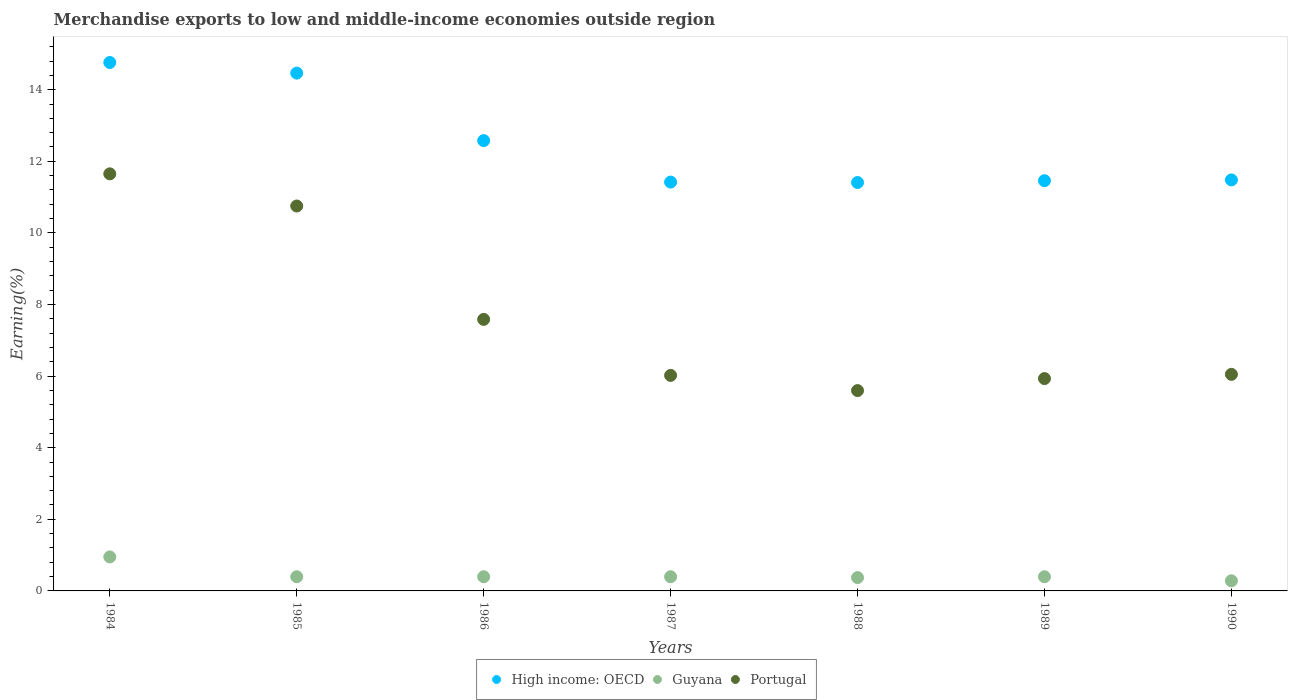What is the percentage of amount earned from merchandise exports in Portugal in 1986?
Your answer should be very brief. 7.58. Across all years, what is the maximum percentage of amount earned from merchandise exports in Portugal?
Offer a very short reply. 11.65. Across all years, what is the minimum percentage of amount earned from merchandise exports in Guyana?
Provide a short and direct response. 0.28. In which year was the percentage of amount earned from merchandise exports in Portugal minimum?
Provide a short and direct response. 1988. What is the total percentage of amount earned from merchandise exports in Portugal in the graph?
Your answer should be very brief. 53.58. What is the difference between the percentage of amount earned from merchandise exports in Guyana in 1985 and that in 1987?
Offer a terse response. -7.184997041775887e-11. What is the difference between the percentage of amount earned from merchandise exports in Guyana in 1984 and the percentage of amount earned from merchandise exports in Portugal in 1989?
Your answer should be very brief. -4.98. What is the average percentage of amount earned from merchandise exports in Portugal per year?
Ensure brevity in your answer.  7.65. In the year 1988, what is the difference between the percentage of amount earned from merchandise exports in Guyana and percentage of amount earned from merchandise exports in Portugal?
Offer a very short reply. -5.22. In how many years, is the percentage of amount earned from merchandise exports in High income: OECD greater than 6.4 %?
Provide a succinct answer. 7. What is the ratio of the percentage of amount earned from merchandise exports in Portugal in 1985 to that in 1988?
Your response must be concise. 1.92. Is the percentage of amount earned from merchandise exports in Portugal in 1988 less than that in 1990?
Offer a very short reply. Yes. What is the difference between the highest and the second highest percentage of amount earned from merchandise exports in High income: OECD?
Offer a very short reply. 0.3. What is the difference between the highest and the lowest percentage of amount earned from merchandise exports in High income: OECD?
Offer a terse response. 3.35. In how many years, is the percentage of amount earned from merchandise exports in Guyana greater than the average percentage of amount earned from merchandise exports in Guyana taken over all years?
Ensure brevity in your answer.  1. Is it the case that in every year, the sum of the percentage of amount earned from merchandise exports in Guyana and percentage of amount earned from merchandise exports in High income: OECD  is greater than the percentage of amount earned from merchandise exports in Portugal?
Provide a short and direct response. Yes. Does the percentage of amount earned from merchandise exports in High income: OECD monotonically increase over the years?
Provide a short and direct response. No. Is the percentage of amount earned from merchandise exports in Portugal strictly greater than the percentage of amount earned from merchandise exports in High income: OECD over the years?
Your response must be concise. No. How many dotlines are there?
Make the answer very short. 3. How many years are there in the graph?
Offer a very short reply. 7. What is the difference between two consecutive major ticks on the Y-axis?
Your answer should be compact. 2. Does the graph contain grids?
Provide a succinct answer. No. Where does the legend appear in the graph?
Provide a succinct answer. Bottom center. How many legend labels are there?
Your response must be concise. 3. How are the legend labels stacked?
Make the answer very short. Horizontal. What is the title of the graph?
Keep it short and to the point. Merchandise exports to low and middle-income economies outside region. Does "Croatia" appear as one of the legend labels in the graph?
Offer a terse response. No. What is the label or title of the Y-axis?
Offer a very short reply. Earning(%). What is the Earning(%) of High income: OECD in 1984?
Give a very brief answer. 14.76. What is the Earning(%) in Guyana in 1984?
Provide a short and direct response. 0.95. What is the Earning(%) in Portugal in 1984?
Make the answer very short. 11.65. What is the Earning(%) in High income: OECD in 1985?
Your answer should be compact. 14.46. What is the Earning(%) in Guyana in 1985?
Offer a very short reply. 0.4. What is the Earning(%) of Portugal in 1985?
Offer a terse response. 10.75. What is the Earning(%) in High income: OECD in 1986?
Offer a very short reply. 12.58. What is the Earning(%) in Guyana in 1986?
Keep it short and to the point. 0.4. What is the Earning(%) of Portugal in 1986?
Keep it short and to the point. 7.58. What is the Earning(%) of High income: OECD in 1987?
Provide a succinct answer. 11.42. What is the Earning(%) of Guyana in 1987?
Your response must be concise. 0.4. What is the Earning(%) of Portugal in 1987?
Provide a short and direct response. 6.02. What is the Earning(%) of High income: OECD in 1988?
Provide a short and direct response. 11.41. What is the Earning(%) in Guyana in 1988?
Offer a very short reply. 0.37. What is the Earning(%) of Portugal in 1988?
Give a very brief answer. 5.6. What is the Earning(%) of High income: OECD in 1989?
Your answer should be very brief. 11.46. What is the Earning(%) of Guyana in 1989?
Keep it short and to the point. 0.4. What is the Earning(%) of Portugal in 1989?
Make the answer very short. 5.93. What is the Earning(%) in High income: OECD in 1990?
Ensure brevity in your answer.  11.48. What is the Earning(%) of Guyana in 1990?
Offer a terse response. 0.28. What is the Earning(%) in Portugal in 1990?
Offer a terse response. 6.05. Across all years, what is the maximum Earning(%) of High income: OECD?
Give a very brief answer. 14.76. Across all years, what is the maximum Earning(%) of Guyana?
Your answer should be compact. 0.95. Across all years, what is the maximum Earning(%) of Portugal?
Your answer should be compact. 11.65. Across all years, what is the minimum Earning(%) of High income: OECD?
Your answer should be very brief. 11.41. Across all years, what is the minimum Earning(%) in Guyana?
Provide a succinct answer. 0.28. Across all years, what is the minimum Earning(%) in Portugal?
Your response must be concise. 5.6. What is the total Earning(%) in High income: OECD in the graph?
Offer a terse response. 87.56. What is the total Earning(%) of Guyana in the graph?
Provide a short and direct response. 3.19. What is the total Earning(%) in Portugal in the graph?
Provide a short and direct response. 53.58. What is the difference between the Earning(%) in High income: OECD in 1984 and that in 1985?
Make the answer very short. 0.3. What is the difference between the Earning(%) of Guyana in 1984 and that in 1985?
Provide a succinct answer. 0.55. What is the difference between the Earning(%) in Portugal in 1984 and that in 1985?
Your response must be concise. 0.9. What is the difference between the Earning(%) in High income: OECD in 1984 and that in 1986?
Your answer should be very brief. 2.18. What is the difference between the Earning(%) in Guyana in 1984 and that in 1986?
Provide a succinct answer. 0.55. What is the difference between the Earning(%) in Portugal in 1984 and that in 1986?
Provide a short and direct response. 4.06. What is the difference between the Earning(%) in High income: OECD in 1984 and that in 1987?
Provide a succinct answer. 3.34. What is the difference between the Earning(%) in Guyana in 1984 and that in 1987?
Your answer should be compact. 0.55. What is the difference between the Earning(%) in Portugal in 1984 and that in 1987?
Provide a succinct answer. 5.63. What is the difference between the Earning(%) of High income: OECD in 1984 and that in 1988?
Your answer should be very brief. 3.35. What is the difference between the Earning(%) of Guyana in 1984 and that in 1988?
Keep it short and to the point. 0.58. What is the difference between the Earning(%) in Portugal in 1984 and that in 1988?
Give a very brief answer. 6.05. What is the difference between the Earning(%) in High income: OECD in 1984 and that in 1989?
Offer a very short reply. 3.3. What is the difference between the Earning(%) of Guyana in 1984 and that in 1989?
Provide a short and direct response. 0.55. What is the difference between the Earning(%) in Portugal in 1984 and that in 1989?
Your response must be concise. 5.72. What is the difference between the Earning(%) in High income: OECD in 1984 and that in 1990?
Give a very brief answer. 3.28. What is the difference between the Earning(%) in Guyana in 1984 and that in 1990?
Your response must be concise. 0.67. What is the difference between the Earning(%) of Portugal in 1984 and that in 1990?
Your answer should be compact. 5.6. What is the difference between the Earning(%) of High income: OECD in 1985 and that in 1986?
Your answer should be compact. 1.89. What is the difference between the Earning(%) in Portugal in 1985 and that in 1986?
Provide a succinct answer. 3.17. What is the difference between the Earning(%) in High income: OECD in 1985 and that in 1987?
Your answer should be compact. 3.04. What is the difference between the Earning(%) of Portugal in 1985 and that in 1987?
Your response must be concise. 4.73. What is the difference between the Earning(%) in High income: OECD in 1985 and that in 1988?
Your response must be concise. 3.06. What is the difference between the Earning(%) of Guyana in 1985 and that in 1988?
Your response must be concise. 0.02. What is the difference between the Earning(%) of Portugal in 1985 and that in 1988?
Give a very brief answer. 5.16. What is the difference between the Earning(%) of High income: OECD in 1985 and that in 1989?
Keep it short and to the point. 3.01. What is the difference between the Earning(%) of Guyana in 1985 and that in 1989?
Provide a short and direct response. 0. What is the difference between the Earning(%) in Portugal in 1985 and that in 1989?
Make the answer very short. 4.82. What is the difference between the Earning(%) of High income: OECD in 1985 and that in 1990?
Offer a very short reply. 2.98. What is the difference between the Earning(%) in Guyana in 1985 and that in 1990?
Keep it short and to the point. 0.11. What is the difference between the Earning(%) in Portugal in 1985 and that in 1990?
Your answer should be compact. 4.7. What is the difference between the Earning(%) of High income: OECD in 1986 and that in 1987?
Your response must be concise. 1.16. What is the difference between the Earning(%) in Portugal in 1986 and that in 1987?
Your answer should be compact. 1.56. What is the difference between the Earning(%) in High income: OECD in 1986 and that in 1988?
Your response must be concise. 1.17. What is the difference between the Earning(%) of Guyana in 1986 and that in 1988?
Your answer should be very brief. 0.02. What is the difference between the Earning(%) of Portugal in 1986 and that in 1988?
Offer a terse response. 1.99. What is the difference between the Earning(%) in High income: OECD in 1986 and that in 1989?
Your answer should be compact. 1.12. What is the difference between the Earning(%) of Portugal in 1986 and that in 1989?
Your response must be concise. 1.65. What is the difference between the Earning(%) of High income: OECD in 1986 and that in 1990?
Provide a succinct answer. 1.1. What is the difference between the Earning(%) of Guyana in 1986 and that in 1990?
Provide a short and direct response. 0.11. What is the difference between the Earning(%) of Portugal in 1986 and that in 1990?
Offer a terse response. 1.54. What is the difference between the Earning(%) in High income: OECD in 1987 and that in 1988?
Keep it short and to the point. 0.01. What is the difference between the Earning(%) of Guyana in 1987 and that in 1988?
Your answer should be compact. 0.02. What is the difference between the Earning(%) in Portugal in 1987 and that in 1988?
Ensure brevity in your answer.  0.42. What is the difference between the Earning(%) in High income: OECD in 1987 and that in 1989?
Provide a short and direct response. -0.04. What is the difference between the Earning(%) of Portugal in 1987 and that in 1989?
Offer a terse response. 0.09. What is the difference between the Earning(%) of High income: OECD in 1987 and that in 1990?
Make the answer very short. -0.06. What is the difference between the Earning(%) of Guyana in 1987 and that in 1990?
Provide a succinct answer. 0.11. What is the difference between the Earning(%) of Portugal in 1987 and that in 1990?
Keep it short and to the point. -0.03. What is the difference between the Earning(%) of High income: OECD in 1988 and that in 1989?
Give a very brief answer. -0.05. What is the difference between the Earning(%) in Guyana in 1988 and that in 1989?
Your answer should be compact. -0.02. What is the difference between the Earning(%) in Portugal in 1988 and that in 1989?
Your answer should be very brief. -0.33. What is the difference between the Earning(%) of High income: OECD in 1988 and that in 1990?
Your answer should be compact. -0.07. What is the difference between the Earning(%) in Guyana in 1988 and that in 1990?
Your response must be concise. 0.09. What is the difference between the Earning(%) in Portugal in 1988 and that in 1990?
Keep it short and to the point. -0.45. What is the difference between the Earning(%) in High income: OECD in 1989 and that in 1990?
Keep it short and to the point. -0.02. What is the difference between the Earning(%) of Guyana in 1989 and that in 1990?
Your answer should be compact. 0.11. What is the difference between the Earning(%) of Portugal in 1989 and that in 1990?
Offer a terse response. -0.12. What is the difference between the Earning(%) of High income: OECD in 1984 and the Earning(%) of Guyana in 1985?
Provide a short and direct response. 14.36. What is the difference between the Earning(%) in High income: OECD in 1984 and the Earning(%) in Portugal in 1985?
Your answer should be compact. 4.01. What is the difference between the Earning(%) of Guyana in 1984 and the Earning(%) of Portugal in 1985?
Your answer should be compact. -9.8. What is the difference between the Earning(%) in High income: OECD in 1984 and the Earning(%) in Guyana in 1986?
Ensure brevity in your answer.  14.36. What is the difference between the Earning(%) of High income: OECD in 1984 and the Earning(%) of Portugal in 1986?
Provide a succinct answer. 7.17. What is the difference between the Earning(%) in Guyana in 1984 and the Earning(%) in Portugal in 1986?
Offer a terse response. -6.63. What is the difference between the Earning(%) in High income: OECD in 1984 and the Earning(%) in Guyana in 1987?
Your answer should be very brief. 14.36. What is the difference between the Earning(%) of High income: OECD in 1984 and the Earning(%) of Portugal in 1987?
Provide a succinct answer. 8.74. What is the difference between the Earning(%) of Guyana in 1984 and the Earning(%) of Portugal in 1987?
Keep it short and to the point. -5.07. What is the difference between the Earning(%) in High income: OECD in 1984 and the Earning(%) in Guyana in 1988?
Your response must be concise. 14.39. What is the difference between the Earning(%) in High income: OECD in 1984 and the Earning(%) in Portugal in 1988?
Keep it short and to the point. 9.16. What is the difference between the Earning(%) in Guyana in 1984 and the Earning(%) in Portugal in 1988?
Your answer should be compact. -4.65. What is the difference between the Earning(%) of High income: OECD in 1984 and the Earning(%) of Guyana in 1989?
Ensure brevity in your answer.  14.36. What is the difference between the Earning(%) in High income: OECD in 1984 and the Earning(%) in Portugal in 1989?
Provide a succinct answer. 8.83. What is the difference between the Earning(%) in Guyana in 1984 and the Earning(%) in Portugal in 1989?
Your response must be concise. -4.98. What is the difference between the Earning(%) of High income: OECD in 1984 and the Earning(%) of Guyana in 1990?
Your response must be concise. 14.48. What is the difference between the Earning(%) in High income: OECD in 1984 and the Earning(%) in Portugal in 1990?
Provide a short and direct response. 8.71. What is the difference between the Earning(%) in Guyana in 1984 and the Earning(%) in Portugal in 1990?
Make the answer very short. -5.1. What is the difference between the Earning(%) in High income: OECD in 1985 and the Earning(%) in Guyana in 1986?
Your answer should be compact. 14.07. What is the difference between the Earning(%) in High income: OECD in 1985 and the Earning(%) in Portugal in 1986?
Provide a short and direct response. 6.88. What is the difference between the Earning(%) in Guyana in 1985 and the Earning(%) in Portugal in 1986?
Make the answer very short. -7.19. What is the difference between the Earning(%) of High income: OECD in 1985 and the Earning(%) of Guyana in 1987?
Your answer should be very brief. 14.07. What is the difference between the Earning(%) in High income: OECD in 1985 and the Earning(%) in Portugal in 1987?
Your response must be concise. 8.44. What is the difference between the Earning(%) in Guyana in 1985 and the Earning(%) in Portugal in 1987?
Offer a very short reply. -5.62. What is the difference between the Earning(%) of High income: OECD in 1985 and the Earning(%) of Guyana in 1988?
Your response must be concise. 14.09. What is the difference between the Earning(%) of High income: OECD in 1985 and the Earning(%) of Portugal in 1988?
Your answer should be compact. 8.87. What is the difference between the Earning(%) in Guyana in 1985 and the Earning(%) in Portugal in 1988?
Make the answer very short. -5.2. What is the difference between the Earning(%) of High income: OECD in 1985 and the Earning(%) of Guyana in 1989?
Your answer should be very brief. 14.07. What is the difference between the Earning(%) of High income: OECD in 1985 and the Earning(%) of Portugal in 1989?
Keep it short and to the point. 8.53. What is the difference between the Earning(%) of Guyana in 1985 and the Earning(%) of Portugal in 1989?
Give a very brief answer. -5.53. What is the difference between the Earning(%) in High income: OECD in 1985 and the Earning(%) in Guyana in 1990?
Provide a succinct answer. 14.18. What is the difference between the Earning(%) in High income: OECD in 1985 and the Earning(%) in Portugal in 1990?
Your response must be concise. 8.41. What is the difference between the Earning(%) of Guyana in 1985 and the Earning(%) of Portugal in 1990?
Keep it short and to the point. -5.65. What is the difference between the Earning(%) of High income: OECD in 1986 and the Earning(%) of Guyana in 1987?
Provide a short and direct response. 12.18. What is the difference between the Earning(%) of High income: OECD in 1986 and the Earning(%) of Portugal in 1987?
Offer a terse response. 6.56. What is the difference between the Earning(%) in Guyana in 1986 and the Earning(%) in Portugal in 1987?
Your answer should be compact. -5.62. What is the difference between the Earning(%) in High income: OECD in 1986 and the Earning(%) in Guyana in 1988?
Make the answer very short. 12.21. What is the difference between the Earning(%) in High income: OECD in 1986 and the Earning(%) in Portugal in 1988?
Your answer should be very brief. 6.98. What is the difference between the Earning(%) of Guyana in 1986 and the Earning(%) of Portugal in 1988?
Ensure brevity in your answer.  -5.2. What is the difference between the Earning(%) of High income: OECD in 1986 and the Earning(%) of Guyana in 1989?
Provide a short and direct response. 12.18. What is the difference between the Earning(%) in High income: OECD in 1986 and the Earning(%) in Portugal in 1989?
Provide a short and direct response. 6.65. What is the difference between the Earning(%) of Guyana in 1986 and the Earning(%) of Portugal in 1989?
Keep it short and to the point. -5.53. What is the difference between the Earning(%) of High income: OECD in 1986 and the Earning(%) of Guyana in 1990?
Provide a succinct answer. 12.29. What is the difference between the Earning(%) in High income: OECD in 1986 and the Earning(%) in Portugal in 1990?
Give a very brief answer. 6.53. What is the difference between the Earning(%) in Guyana in 1986 and the Earning(%) in Portugal in 1990?
Offer a terse response. -5.65. What is the difference between the Earning(%) in High income: OECD in 1987 and the Earning(%) in Guyana in 1988?
Offer a very short reply. 11.05. What is the difference between the Earning(%) of High income: OECD in 1987 and the Earning(%) of Portugal in 1988?
Your answer should be compact. 5.82. What is the difference between the Earning(%) in Guyana in 1987 and the Earning(%) in Portugal in 1988?
Your answer should be compact. -5.2. What is the difference between the Earning(%) of High income: OECD in 1987 and the Earning(%) of Guyana in 1989?
Make the answer very short. 11.02. What is the difference between the Earning(%) in High income: OECD in 1987 and the Earning(%) in Portugal in 1989?
Your answer should be compact. 5.49. What is the difference between the Earning(%) of Guyana in 1987 and the Earning(%) of Portugal in 1989?
Your response must be concise. -5.53. What is the difference between the Earning(%) in High income: OECD in 1987 and the Earning(%) in Guyana in 1990?
Provide a short and direct response. 11.14. What is the difference between the Earning(%) of High income: OECD in 1987 and the Earning(%) of Portugal in 1990?
Offer a very short reply. 5.37. What is the difference between the Earning(%) of Guyana in 1987 and the Earning(%) of Portugal in 1990?
Provide a short and direct response. -5.65. What is the difference between the Earning(%) in High income: OECD in 1988 and the Earning(%) in Guyana in 1989?
Your answer should be very brief. 11.01. What is the difference between the Earning(%) in High income: OECD in 1988 and the Earning(%) in Portugal in 1989?
Ensure brevity in your answer.  5.48. What is the difference between the Earning(%) of Guyana in 1988 and the Earning(%) of Portugal in 1989?
Give a very brief answer. -5.56. What is the difference between the Earning(%) in High income: OECD in 1988 and the Earning(%) in Guyana in 1990?
Provide a short and direct response. 11.12. What is the difference between the Earning(%) in High income: OECD in 1988 and the Earning(%) in Portugal in 1990?
Your response must be concise. 5.36. What is the difference between the Earning(%) in Guyana in 1988 and the Earning(%) in Portugal in 1990?
Ensure brevity in your answer.  -5.68. What is the difference between the Earning(%) of High income: OECD in 1989 and the Earning(%) of Guyana in 1990?
Your response must be concise. 11.17. What is the difference between the Earning(%) in High income: OECD in 1989 and the Earning(%) in Portugal in 1990?
Your answer should be compact. 5.41. What is the difference between the Earning(%) of Guyana in 1989 and the Earning(%) of Portugal in 1990?
Provide a short and direct response. -5.65. What is the average Earning(%) of High income: OECD per year?
Your answer should be very brief. 12.51. What is the average Earning(%) in Guyana per year?
Provide a short and direct response. 0.46. What is the average Earning(%) in Portugal per year?
Offer a very short reply. 7.65. In the year 1984, what is the difference between the Earning(%) in High income: OECD and Earning(%) in Guyana?
Provide a short and direct response. 13.81. In the year 1984, what is the difference between the Earning(%) in High income: OECD and Earning(%) in Portugal?
Offer a very short reply. 3.11. In the year 1984, what is the difference between the Earning(%) of Guyana and Earning(%) of Portugal?
Ensure brevity in your answer.  -10.7. In the year 1985, what is the difference between the Earning(%) in High income: OECD and Earning(%) in Guyana?
Offer a terse response. 14.07. In the year 1985, what is the difference between the Earning(%) of High income: OECD and Earning(%) of Portugal?
Provide a short and direct response. 3.71. In the year 1985, what is the difference between the Earning(%) of Guyana and Earning(%) of Portugal?
Provide a short and direct response. -10.35. In the year 1986, what is the difference between the Earning(%) in High income: OECD and Earning(%) in Guyana?
Give a very brief answer. 12.18. In the year 1986, what is the difference between the Earning(%) of High income: OECD and Earning(%) of Portugal?
Ensure brevity in your answer.  4.99. In the year 1986, what is the difference between the Earning(%) of Guyana and Earning(%) of Portugal?
Provide a succinct answer. -7.19. In the year 1987, what is the difference between the Earning(%) in High income: OECD and Earning(%) in Guyana?
Your answer should be very brief. 11.02. In the year 1987, what is the difference between the Earning(%) in High income: OECD and Earning(%) in Portugal?
Your answer should be compact. 5.4. In the year 1987, what is the difference between the Earning(%) in Guyana and Earning(%) in Portugal?
Ensure brevity in your answer.  -5.62. In the year 1988, what is the difference between the Earning(%) of High income: OECD and Earning(%) of Guyana?
Your answer should be very brief. 11.03. In the year 1988, what is the difference between the Earning(%) in High income: OECD and Earning(%) in Portugal?
Provide a short and direct response. 5.81. In the year 1988, what is the difference between the Earning(%) of Guyana and Earning(%) of Portugal?
Ensure brevity in your answer.  -5.22. In the year 1989, what is the difference between the Earning(%) in High income: OECD and Earning(%) in Guyana?
Offer a very short reply. 11.06. In the year 1989, what is the difference between the Earning(%) of High income: OECD and Earning(%) of Portugal?
Keep it short and to the point. 5.53. In the year 1989, what is the difference between the Earning(%) in Guyana and Earning(%) in Portugal?
Your response must be concise. -5.53. In the year 1990, what is the difference between the Earning(%) in High income: OECD and Earning(%) in Guyana?
Your answer should be compact. 11.2. In the year 1990, what is the difference between the Earning(%) in High income: OECD and Earning(%) in Portugal?
Give a very brief answer. 5.43. In the year 1990, what is the difference between the Earning(%) in Guyana and Earning(%) in Portugal?
Ensure brevity in your answer.  -5.77. What is the ratio of the Earning(%) of High income: OECD in 1984 to that in 1985?
Give a very brief answer. 1.02. What is the ratio of the Earning(%) of Guyana in 1984 to that in 1985?
Give a very brief answer. 2.4. What is the ratio of the Earning(%) of Portugal in 1984 to that in 1985?
Offer a terse response. 1.08. What is the ratio of the Earning(%) in High income: OECD in 1984 to that in 1986?
Give a very brief answer. 1.17. What is the ratio of the Earning(%) of Guyana in 1984 to that in 1986?
Provide a short and direct response. 2.4. What is the ratio of the Earning(%) of Portugal in 1984 to that in 1986?
Offer a very short reply. 1.54. What is the ratio of the Earning(%) in High income: OECD in 1984 to that in 1987?
Your answer should be compact. 1.29. What is the ratio of the Earning(%) in Guyana in 1984 to that in 1987?
Give a very brief answer. 2.4. What is the ratio of the Earning(%) of Portugal in 1984 to that in 1987?
Your answer should be very brief. 1.94. What is the ratio of the Earning(%) in High income: OECD in 1984 to that in 1988?
Your answer should be very brief. 1.29. What is the ratio of the Earning(%) in Guyana in 1984 to that in 1988?
Provide a succinct answer. 2.55. What is the ratio of the Earning(%) in Portugal in 1984 to that in 1988?
Offer a terse response. 2.08. What is the ratio of the Earning(%) in High income: OECD in 1984 to that in 1989?
Ensure brevity in your answer.  1.29. What is the ratio of the Earning(%) of Guyana in 1984 to that in 1989?
Offer a very short reply. 2.4. What is the ratio of the Earning(%) of Portugal in 1984 to that in 1989?
Your response must be concise. 1.96. What is the ratio of the Earning(%) of High income: OECD in 1984 to that in 1990?
Offer a very short reply. 1.29. What is the ratio of the Earning(%) of Guyana in 1984 to that in 1990?
Your response must be concise. 3.35. What is the ratio of the Earning(%) in Portugal in 1984 to that in 1990?
Make the answer very short. 1.93. What is the ratio of the Earning(%) of High income: OECD in 1985 to that in 1986?
Keep it short and to the point. 1.15. What is the ratio of the Earning(%) in Guyana in 1985 to that in 1986?
Keep it short and to the point. 1. What is the ratio of the Earning(%) of Portugal in 1985 to that in 1986?
Make the answer very short. 1.42. What is the ratio of the Earning(%) in High income: OECD in 1985 to that in 1987?
Provide a short and direct response. 1.27. What is the ratio of the Earning(%) in Portugal in 1985 to that in 1987?
Give a very brief answer. 1.79. What is the ratio of the Earning(%) of High income: OECD in 1985 to that in 1988?
Your answer should be compact. 1.27. What is the ratio of the Earning(%) in Guyana in 1985 to that in 1988?
Make the answer very short. 1.06. What is the ratio of the Earning(%) in Portugal in 1985 to that in 1988?
Ensure brevity in your answer.  1.92. What is the ratio of the Earning(%) in High income: OECD in 1985 to that in 1989?
Provide a short and direct response. 1.26. What is the ratio of the Earning(%) of Guyana in 1985 to that in 1989?
Your answer should be compact. 1. What is the ratio of the Earning(%) of Portugal in 1985 to that in 1989?
Offer a terse response. 1.81. What is the ratio of the Earning(%) in High income: OECD in 1985 to that in 1990?
Keep it short and to the point. 1.26. What is the ratio of the Earning(%) of Guyana in 1985 to that in 1990?
Make the answer very short. 1.4. What is the ratio of the Earning(%) of Portugal in 1985 to that in 1990?
Keep it short and to the point. 1.78. What is the ratio of the Earning(%) of High income: OECD in 1986 to that in 1987?
Provide a short and direct response. 1.1. What is the ratio of the Earning(%) of Portugal in 1986 to that in 1987?
Your response must be concise. 1.26. What is the ratio of the Earning(%) in High income: OECD in 1986 to that in 1988?
Ensure brevity in your answer.  1.1. What is the ratio of the Earning(%) in Guyana in 1986 to that in 1988?
Make the answer very short. 1.06. What is the ratio of the Earning(%) in Portugal in 1986 to that in 1988?
Your response must be concise. 1.36. What is the ratio of the Earning(%) of High income: OECD in 1986 to that in 1989?
Keep it short and to the point. 1.1. What is the ratio of the Earning(%) in Portugal in 1986 to that in 1989?
Ensure brevity in your answer.  1.28. What is the ratio of the Earning(%) in High income: OECD in 1986 to that in 1990?
Your answer should be compact. 1.1. What is the ratio of the Earning(%) in Guyana in 1986 to that in 1990?
Offer a terse response. 1.4. What is the ratio of the Earning(%) in Portugal in 1986 to that in 1990?
Give a very brief answer. 1.25. What is the ratio of the Earning(%) of Guyana in 1987 to that in 1988?
Your response must be concise. 1.06. What is the ratio of the Earning(%) of Portugal in 1987 to that in 1988?
Give a very brief answer. 1.08. What is the ratio of the Earning(%) in Guyana in 1987 to that in 1989?
Your response must be concise. 1. What is the ratio of the Earning(%) of Portugal in 1987 to that in 1989?
Keep it short and to the point. 1.02. What is the ratio of the Earning(%) of Guyana in 1987 to that in 1990?
Offer a very short reply. 1.4. What is the ratio of the Earning(%) in High income: OECD in 1988 to that in 1989?
Provide a succinct answer. 1. What is the ratio of the Earning(%) of Guyana in 1988 to that in 1989?
Ensure brevity in your answer.  0.94. What is the ratio of the Earning(%) of Portugal in 1988 to that in 1989?
Your answer should be compact. 0.94. What is the ratio of the Earning(%) in Guyana in 1988 to that in 1990?
Offer a terse response. 1.32. What is the ratio of the Earning(%) of Portugal in 1988 to that in 1990?
Keep it short and to the point. 0.93. What is the ratio of the Earning(%) in High income: OECD in 1989 to that in 1990?
Offer a terse response. 1. What is the ratio of the Earning(%) of Guyana in 1989 to that in 1990?
Offer a very short reply. 1.4. What is the ratio of the Earning(%) in Portugal in 1989 to that in 1990?
Make the answer very short. 0.98. What is the difference between the highest and the second highest Earning(%) of High income: OECD?
Give a very brief answer. 0.3. What is the difference between the highest and the second highest Earning(%) of Guyana?
Make the answer very short. 0.55. What is the difference between the highest and the second highest Earning(%) of Portugal?
Provide a short and direct response. 0.9. What is the difference between the highest and the lowest Earning(%) in High income: OECD?
Keep it short and to the point. 3.35. What is the difference between the highest and the lowest Earning(%) in Guyana?
Offer a very short reply. 0.67. What is the difference between the highest and the lowest Earning(%) of Portugal?
Offer a terse response. 6.05. 